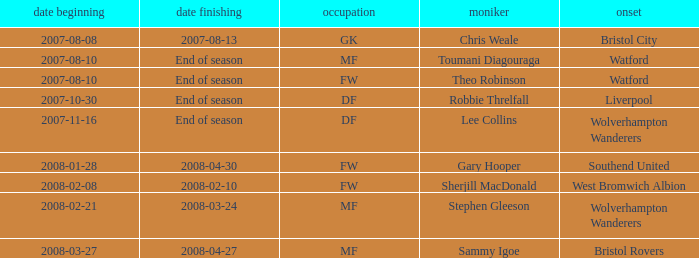What date did Toumani Diagouraga, who played position MF, start? 2007-08-10. 